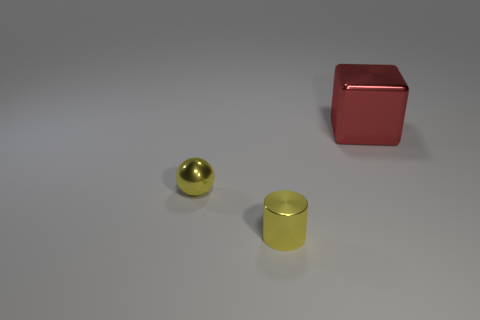How many cylinders are tiny matte things or small yellow things?
Ensure brevity in your answer.  1. Is the number of tiny metallic objects greater than the number of shiny things?
Your answer should be compact. No. What number of yellow spheres have the same size as the metal cylinder?
Ensure brevity in your answer.  1. What shape is the metal thing that is the same color as the small cylinder?
Provide a short and direct response. Sphere. What number of things are either things that are in front of the big red block or small brown cylinders?
Your answer should be compact. 2. Are there fewer tiny cylinders than yellow objects?
Make the answer very short. Yes. There is a small yellow object that is the same material as the small cylinder; what shape is it?
Provide a short and direct response. Sphere. Are there any things in front of the large red metallic thing?
Keep it short and to the point. Yes. Are there fewer small objects that are behind the red metal thing than small green cylinders?
Make the answer very short. No. What color is the metallic sphere?
Provide a short and direct response. Yellow. 